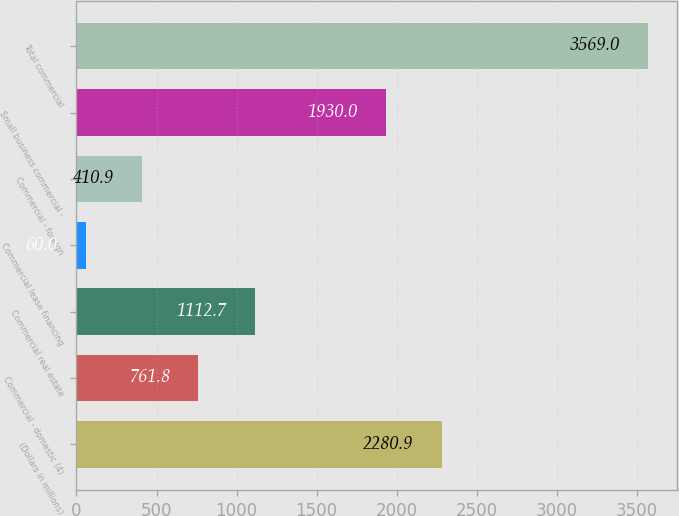Convert chart to OTSL. <chart><loc_0><loc_0><loc_500><loc_500><bar_chart><fcel>(Dollars in millions)<fcel>Commercial - domestic (4)<fcel>Commercial real estate<fcel>Commercial lease financing<fcel>Commercial - foreign<fcel>Small business commercial -<fcel>Total commercial<nl><fcel>2280.9<fcel>761.8<fcel>1112.7<fcel>60<fcel>410.9<fcel>1930<fcel>3569<nl></chart> 